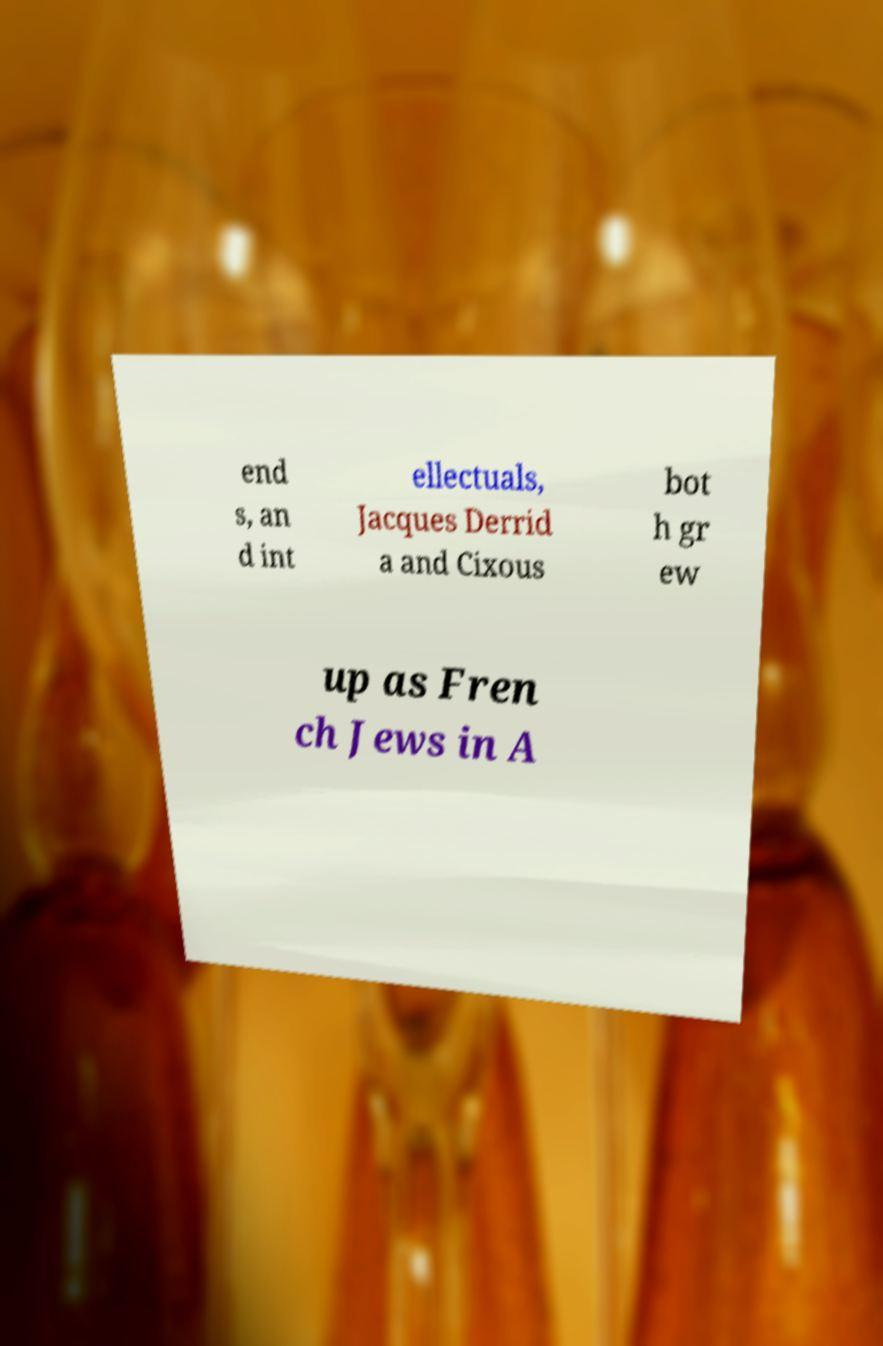I need the written content from this picture converted into text. Can you do that? end s, an d int ellectuals, Jacques Derrid a and Cixous bot h gr ew up as Fren ch Jews in A 